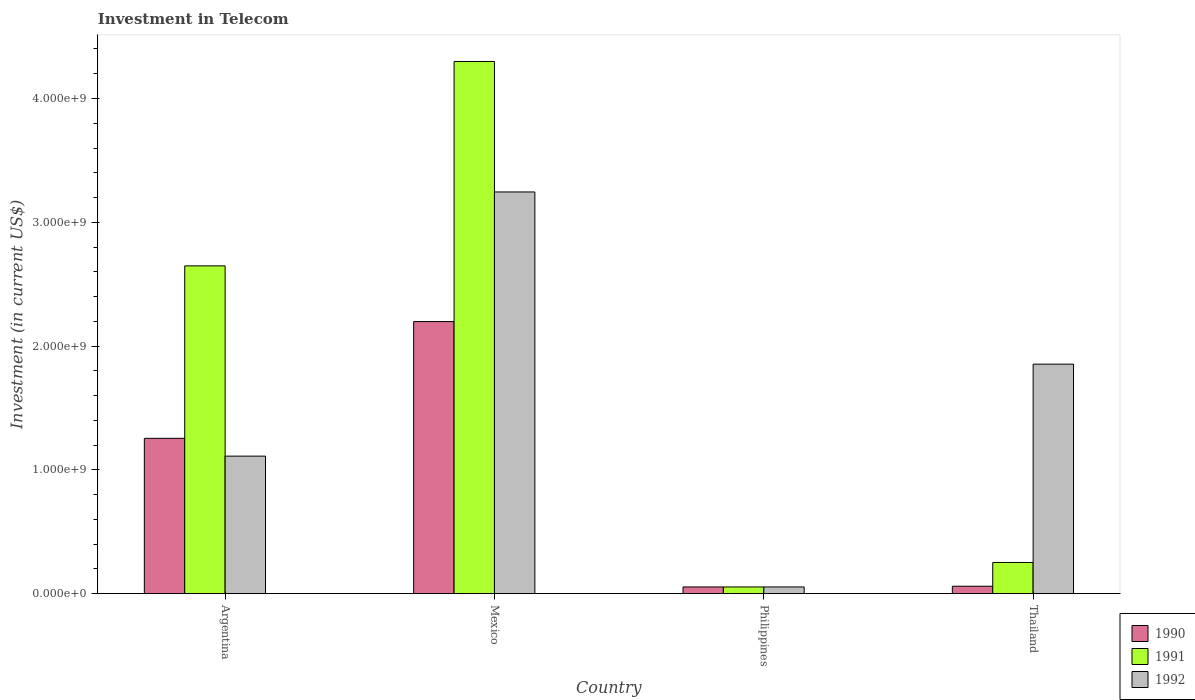Are the number of bars per tick equal to the number of legend labels?
Offer a terse response. Yes. Are the number of bars on each tick of the X-axis equal?
Provide a succinct answer. Yes. What is the label of the 4th group of bars from the left?
Ensure brevity in your answer.  Thailand. In how many cases, is the number of bars for a given country not equal to the number of legend labels?
Offer a terse response. 0. What is the amount invested in telecom in 1991 in Thailand?
Your answer should be very brief. 2.52e+08. Across all countries, what is the maximum amount invested in telecom in 1991?
Provide a short and direct response. 4.30e+09. Across all countries, what is the minimum amount invested in telecom in 1990?
Offer a terse response. 5.42e+07. In which country was the amount invested in telecom in 1992 maximum?
Make the answer very short. Mexico. What is the total amount invested in telecom in 1990 in the graph?
Provide a succinct answer. 3.57e+09. What is the difference between the amount invested in telecom in 1990 in Mexico and that in Thailand?
Provide a short and direct response. 2.14e+09. What is the difference between the amount invested in telecom in 1991 in Thailand and the amount invested in telecom in 1992 in Argentina?
Your answer should be very brief. -8.59e+08. What is the average amount invested in telecom in 1990 per country?
Provide a short and direct response. 8.92e+08. What is the difference between the amount invested in telecom of/in 1990 and amount invested in telecom of/in 1991 in Mexico?
Make the answer very short. -2.10e+09. What is the ratio of the amount invested in telecom in 1990 in Mexico to that in Philippines?
Make the answer very short. 40.55. Is the difference between the amount invested in telecom in 1990 in Philippines and Thailand greater than the difference between the amount invested in telecom in 1991 in Philippines and Thailand?
Keep it short and to the point. Yes. What is the difference between the highest and the second highest amount invested in telecom in 1991?
Your answer should be compact. 1.65e+09. What is the difference between the highest and the lowest amount invested in telecom in 1990?
Give a very brief answer. 2.14e+09. In how many countries, is the amount invested in telecom in 1990 greater than the average amount invested in telecom in 1990 taken over all countries?
Offer a very short reply. 2. Is the sum of the amount invested in telecom in 1990 in Argentina and Mexico greater than the maximum amount invested in telecom in 1991 across all countries?
Your answer should be compact. No. Is it the case that in every country, the sum of the amount invested in telecom in 1990 and amount invested in telecom in 1992 is greater than the amount invested in telecom in 1991?
Offer a terse response. No. Are all the bars in the graph horizontal?
Make the answer very short. No. What is the difference between two consecutive major ticks on the Y-axis?
Keep it short and to the point. 1.00e+09. Are the values on the major ticks of Y-axis written in scientific E-notation?
Ensure brevity in your answer.  Yes. Does the graph contain any zero values?
Ensure brevity in your answer.  No. Does the graph contain grids?
Provide a short and direct response. No. Where does the legend appear in the graph?
Provide a short and direct response. Bottom right. How many legend labels are there?
Offer a very short reply. 3. How are the legend labels stacked?
Your answer should be compact. Vertical. What is the title of the graph?
Offer a very short reply. Investment in Telecom. Does "1996" appear as one of the legend labels in the graph?
Keep it short and to the point. No. What is the label or title of the X-axis?
Your answer should be very brief. Country. What is the label or title of the Y-axis?
Your response must be concise. Investment (in current US$). What is the Investment (in current US$) in 1990 in Argentina?
Offer a terse response. 1.25e+09. What is the Investment (in current US$) of 1991 in Argentina?
Provide a short and direct response. 2.65e+09. What is the Investment (in current US$) of 1992 in Argentina?
Give a very brief answer. 1.11e+09. What is the Investment (in current US$) of 1990 in Mexico?
Your answer should be very brief. 2.20e+09. What is the Investment (in current US$) in 1991 in Mexico?
Ensure brevity in your answer.  4.30e+09. What is the Investment (in current US$) of 1992 in Mexico?
Ensure brevity in your answer.  3.24e+09. What is the Investment (in current US$) in 1990 in Philippines?
Your response must be concise. 5.42e+07. What is the Investment (in current US$) of 1991 in Philippines?
Provide a short and direct response. 5.42e+07. What is the Investment (in current US$) in 1992 in Philippines?
Provide a short and direct response. 5.42e+07. What is the Investment (in current US$) of 1990 in Thailand?
Your answer should be very brief. 6.00e+07. What is the Investment (in current US$) in 1991 in Thailand?
Your response must be concise. 2.52e+08. What is the Investment (in current US$) in 1992 in Thailand?
Keep it short and to the point. 1.85e+09. Across all countries, what is the maximum Investment (in current US$) in 1990?
Give a very brief answer. 2.20e+09. Across all countries, what is the maximum Investment (in current US$) of 1991?
Your answer should be very brief. 4.30e+09. Across all countries, what is the maximum Investment (in current US$) of 1992?
Provide a short and direct response. 3.24e+09. Across all countries, what is the minimum Investment (in current US$) in 1990?
Offer a terse response. 5.42e+07. Across all countries, what is the minimum Investment (in current US$) in 1991?
Offer a very short reply. 5.42e+07. Across all countries, what is the minimum Investment (in current US$) in 1992?
Provide a succinct answer. 5.42e+07. What is the total Investment (in current US$) in 1990 in the graph?
Your answer should be very brief. 3.57e+09. What is the total Investment (in current US$) of 1991 in the graph?
Provide a succinct answer. 7.25e+09. What is the total Investment (in current US$) in 1992 in the graph?
Give a very brief answer. 6.26e+09. What is the difference between the Investment (in current US$) in 1990 in Argentina and that in Mexico?
Offer a very short reply. -9.43e+08. What is the difference between the Investment (in current US$) of 1991 in Argentina and that in Mexico?
Give a very brief answer. -1.65e+09. What is the difference between the Investment (in current US$) in 1992 in Argentina and that in Mexico?
Ensure brevity in your answer.  -2.13e+09. What is the difference between the Investment (in current US$) in 1990 in Argentina and that in Philippines?
Keep it short and to the point. 1.20e+09. What is the difference between the Investment (in current US$) in 1991 in Argentina and that in Philippines?
Your answer should be compact. 2.59e+09. What is the difference between the Investment (in current US$) in 1992 in Argentina and that in Philippines?
Your response must be concise. 1.06e+09. What is the difference between the Investment (in current US$) of 1990 in Argentina and that in Thailand?
Offer a terse response. 1.19e+09. What is the difference between the Investment (in current US$) of 1991 in Argentina and that in Thailand?
Provide a short and direct response. 2.40e+09. What is the difference between the Investment (in current US$) of 1992 in Argentina and that in Thailand?
Your answer should be very brief. -7.43e+08. What is the difference between the Investment (in current US$) of 1990 in Mexico and that in Philippines?
Your response must be concise. 2.14e+09. What is the difference between the Investment (in current US$) in 1991 in Mexico and that in Philippines?
Provide a succinct answer. 4.24e+09. What is the difference between the Investment (in current US$) in 1992 in Mexico and that in Philippines?
Offer a terse response. 3.19e+09. What is the difference between the Investment (in current US$) of 1990 in Mexico and that in Thailand?
Your answer should be compact. 2.14e+09. What is the difference between the Investment (in current US$) of 1991 in Mexico and that in Thailand?
Keep it short and to the point. 4.05e+09. What is the difference between the Investment (in current US$) in 1992 in Mexico and that in Thailand?
Make the answer very short. 1.39e+09. What is the difference between the Investment (in current US$) in 1990 in Philippines and that in Thailand?
Provide a succinct answer. -5.80e+06. What is the difference between the Investment (in current US$) in 1991 in Philippines and that in Thailand?
Make the answer very short. -1.98e+08. What is the difference between the Investment (in current US$) in 1992 in Philippines and that in Thailand?
Provide a short and direct response. -1.80e+09. What is the difference between the Investment (in current US$) in 1990 in Argentina and the Investment (in current US$) in 1991 in Mexico?
Keep it short and to the point. -3.04e+09. What is the difference between the Investment (in current US$) of 1990 in Argentina and the Investment (in current US$) of 1992 in Mexico?
Offer a terse response. -1.99e+09. What is the difference between the Investment (in current US$) of 1991 in Argentina and the Investment (in current US$) of 1992 in Mexico?
Make the answer very short. -5.97e+08. What is the difference between the Investment (in current US$) in 1990 in Argentina and the Investment (in current US$) in 1991 in Philippines?
Give a very brief answer. 1.20e+09. What is the difference between the Investment (in current US$) in 1990 in Argentina and the Investment (in current US$) in 1992 in Philippines?
Keep it short and to the point. 1.20e+09. What is the difference between the Investment (in current US$) of 1991 in Argentina and the Investment (in current US$) of 1992 in Philippines?
Your response must be concise. 2.59e+09. What is the difference between the Investment (in current US$) of 1990 in Argentina and the Investment (in current US$) of 1991 in Thailand?
Provide a short and direct response. 1.00e+09. What is the difference between the Investment (in current US$) of 1990 in Argentina and the Investment (in current US$) of 1992 in Thailand?
Your answer should be very brief. -5.99e+08. What is the difference between the Investment (in current US$) in 1991 in Argentina and the Investment (in current US$) in 1992 in Thailand?
Your answer should be very brief. 7.94e+08. What is the difference between the Investment (in current US$) in 1990 in Mexico and the Investment (in current US$) in 1991 in Philippines?
Offer a terse response. 2.14e+09. What is the difference between the Investment (in current US$) of 1990 in Mexico and the Investment (in current US$) of 1992 in Philippines?
Keep it short and to the point. 2.14e+09. What is the difference between the Investment (in current US$) in 1991 in Mexico and the Investment (in current US$) in 1992 in Philippines?
Your response must be concise. 4.24e+09. What is the difference between the Investment (in current US$) in 1990 in Mexico and the Investment (in current US$) in 1991 in Thailand?
Offer a terse response. 1.95e+09. What is the difference between the Investment (in current US$) of 1990 in Mexico and the Investment (in current US$) of 1992 in Thailand?
Provide a succinct answer. 3.44e+08. What is the difference between the Investment (in current US$) in 1991 in Mexico and the Investment (in current US$) in 1992 in Thailand?
Your answer should be compact. 2.44e+09. What is the difference between the Investment (in current US$) in 1990 in Philippines and the Investment (in current US$) in 1991 in Thailand?
Ensure brevity in your answer.  -1.98e+08. What is the difference between the Investment (in current US$) in 1990 in Philippines and the Investment (in current US$) in 1992 in Thailand?
Ensure brevity in your answer.  -1.80e+09. What is the difference between the Investment (in current US$) in 1991 in Philippines and the Investment (in current US$) in 1992 in Thailand?
Offer a very short reply. -1.80e+09. What is the average Investment (in current US$) of 1990 per country?
Provide a short and direct response. 8.92e+08. What is the average Investment (in current US$) of 1991 per country?
Offer a very short reply. 1.81e+09. What is the average Investment (in current US$) of 1992 per country?
Provide a succinct answer. 1.57e+09. What is the difference between the Investment (in current US$) in 1990 and Investment (in current US$) in 1991 in Argentina?
Give a very brief answer. -1.39e+09. What is the difference between the Investment (in current US$) of 1990 and Investment (in current US$) of 1992 in Argentina?
Offer a very short reply. 1.44e+08. What is the difference between the Investment (in current US$) of 1991 and Investment (in current US$) of 1992 in Argentina?
Your response must be concise. 1.54e+09. What is the difference between the Investment (in current US$) of 1990 and Investment (in current US$) of 1991 in Mexico?
Provide a short and direct response. -2.10e+09. What is the difference between the Investment (in current US$) of 1990 and Investment (in current US$) of 1992 in Mexico?
Provide a succinct answer. -1.05e+09. What is the difference between the Investment (in current US$) of 1991 and Investment (in current US$) of 1992 in Mexico?
Your response must be concise. 1.05e+09. What is the difference between the Investment (in current US$) in 1990 and Investment (in current US$) in 1991 in Philippines?
Keep it short and to the point. 0. What is the difference between the Investment (in current US$) of 1990 and Investment (in current US$) of 1992 in Philippines?
Your answer should be compact. 0. What is the difference between the Investment (in current US$) in 1990 and Investment (in current US$) in 1991 in Thailand?
Make the answer very short. -1.92e+08. What is the difference between the Investment (in current US$) of 1990 and Investment (in current US$) of 1992 in Thailand?
Make the answer very short. -1.79e+09. What is the difference between the Investment (in current US$) in 1991 and Investment (in current US$) in 1992 in Thailand?
Give a very brief answer. -1.60e+09. What is the ratio of the Investment (in current US$) of 1990 in Argentina to that in Mexico?
Provide a short and direct response. 0.57. What is the ratio of the Investment (in current US$) of 1991 in Argentina to that in Mexico?
Make the answer very short. 0.62. What is the ratio of the Investment (in current US$) in 1992 in Argentina to that in Mexico?
Your answer should be very brief. 0.34. What is the ratio of the Investment (in current US$) of 1990 in Argentina to that in Philippines?
Provide a succinct answer. 23.15. What is the ratio of the Investment (in current US$) in 1991 in Argentina to that in Philippines?
Offer a very short reply. 48.86. What is the ratio of the Investment (in current US$) of 1992 in Argentina to that in Philippines?
Make the answer very short. 20.5. What is the ratio of the Investment (in current US$) in 1990 in Argentina to that in Thailand?
Make the answer very short. 20.91. What is the ratio of the Investment (in current US$) of 1991 in Argentina to that in Thailand?
Your answer should be very brief. 10.51. What is the ratio of the Investment (in current US$) in 1992 in Argentina to that in Thailand?
Offer a terse response. 0.6. What is the ratio of the Investment (in current US$) in 1990 in Mexico to that in Philippines?
Give a very brief answer. 40.55. What is the ratio of the Investment (in current US$) in 1991 in Mexico to that in Philippines?
Your answer should be very brief. 79.32. What is the ratio of the Investment (in current US$) of 1992 in Mexico to that in Philippines?
Give a very brief answer. 59.87. What is the ratio of the Investment (in current US$) of 1990 in Mexico to that in Thailand?
Ensure brevity in your answer.  36.63. What is the ratio of the Investment (in current US$) of 1991 in Mexico to that in Thailand?
Give a very brief answer. 17.06. What is the ratio of the Investment (in current US$) in 1992 in Mexico to that in Thailand?
Your answer should be compact. 1.75. What is the ratio of the Investment (in current US$) in 1990 in Philippines to that in Thailand?
Keep it short and to the point. 0.9. What is the ratio of the Investment (in current US$) of 1991 in Philippines to that in Thailand?
Keep it short and to the point. 0.22. What is the ratio of the Investment (in current US$) of 1992 in Philippines to that in Thailand?
Provide a succinct answer. 0.03. What is the difference between the highest and the second highest Investment (in current US$) in 1990?
Keep it short and to the point. 9.43e+08. What is the difference between the highest and the second highest Investment (in current US$) of 1991?
Your response must be concise. 1.65e+09. What is the difference between the highest and the second highest Investment (in current US$) of 1992?
Offer a terse response. 1.39e+09. What is the difference between the highest and the lowest Investment (in current US$) of 1990?
Your answer should be compact. 2.14e+09. What is the difference between the highest and the lowest Investment (in current US$) of 1991?
Provide a succinct answer. 4.24e+09. What is the difference between the highest and the lowest Investment (in current US$) of 1992?
Provide a succinct answer. 3.19e+09. 